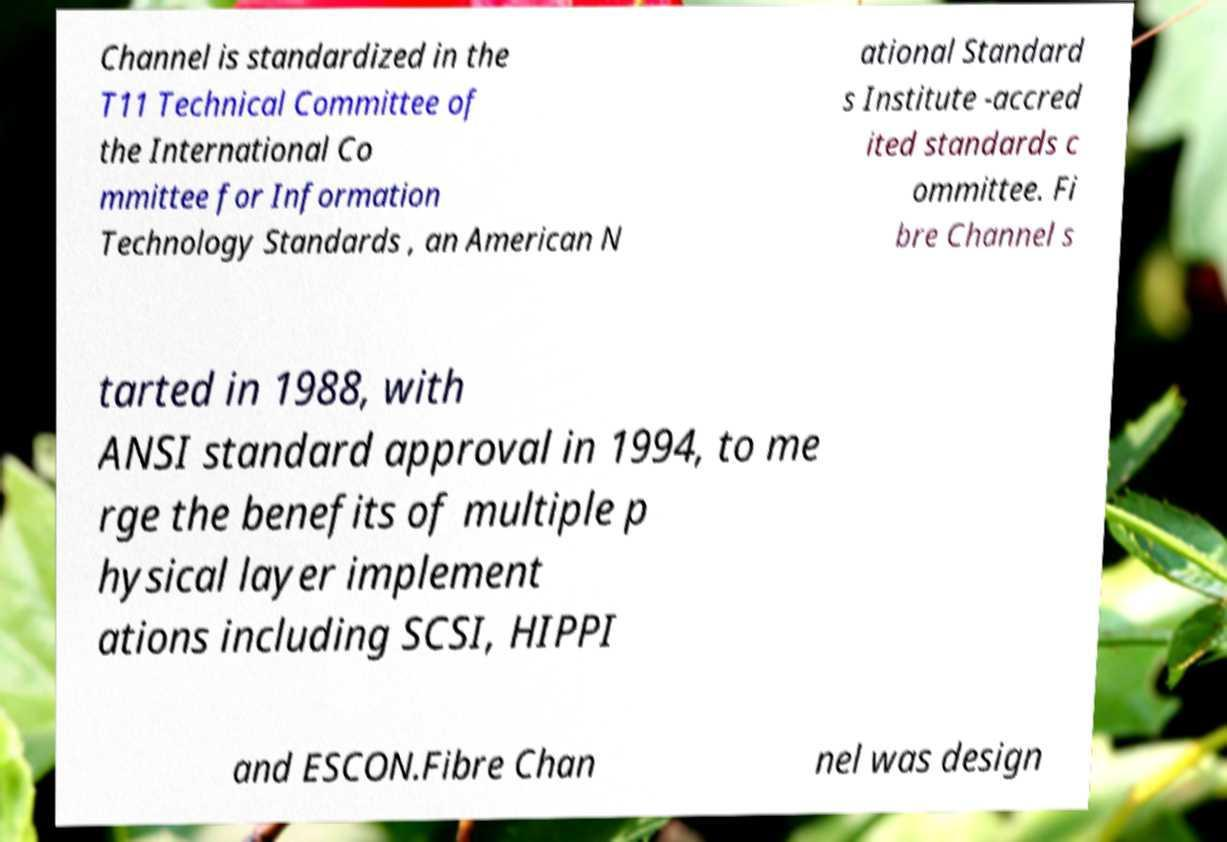Could you extract and type out the text from this image? Channel is standardized in the T11 Technical Committee of the International Co mmittee for Information Technology Standards , an American N ational Standard s Institute -accred ited standards c ommittee. Fi bre Channel s tarted in 1988, with ANSI standard approval in 1994, to me rge the benefits of multiple p hysical layer implement ations including SCSI, HIPPI and ESCON.Fibre Chan nel was design 